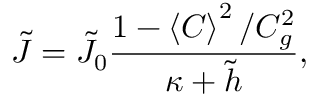Convert formula to latex. <formula><loc_0><loc_0><loc_500><loc_500>\tilde { J } = \tilde { J } _ { 0 } \frac { 1 - \left \langle C \right \rangle ^ { 2 } / C _ { g } ^ { 2 } } { \kappa + \tilde { h } } ,</formula> 